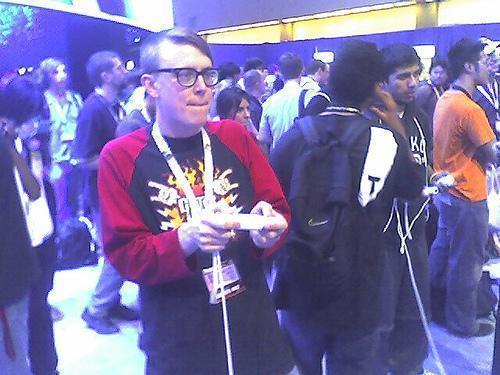What is the man in the black glasses using the white remote to do?
Indicate the correct response and explain using: 'Answer: answer
Rationale: rationale.'
Options: Power tv, open door, play games, control robot. Answer: play games.
Rationale: The man is holding a game remote with a determined look on his face so he's definitely playing a game. 